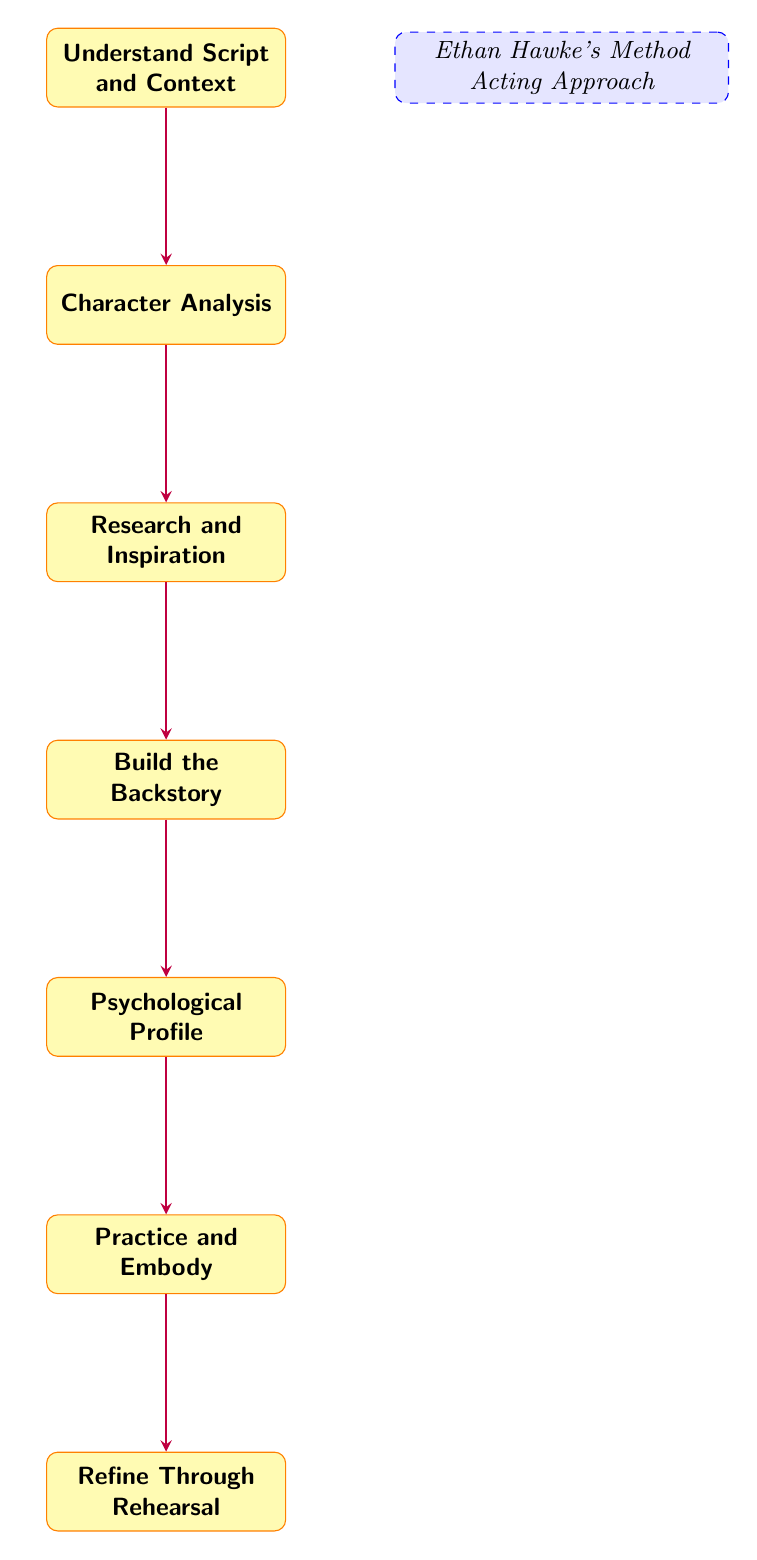What is the first step in the character backstory creation process? The diagram shows "Understand Script and Context" as the first node, indicating it is the initial step in the process.
Answer: Understand Script and Context How many nodes are there in the diagram? By counting the nodes listed in the diagram, there are a total of seven nodes representing steps in the process.
Answer: 7 What is the last step in the process? Looking at the bottom of the flow chart, "Refine Through Rehearsal" is the final node, indicating it is the last step in the character backstory creation process.
Answer: Refine Through Rehearsal What step follows "Character Analysis"? The arrow leading down from "Character Analysis" points to "Research and Inspiration," showing that this is the subsequent step in the flow chart.
Answer: Research and Inspiration Which step develops the character's personality traits? The node labeled "Psychological Profile" directly indicates that this step focuses on developing the character's personality traits, habits, fears, and motivations.
Answer: Psychological Profile How many arrows connect the nodes? The diagram shows six arrows connecting the seven nodes, illustrating the steps’ flow from start to finish.
Answer: 6 What is the relationship between "Build the Backstory" and "Psychological Profile"? The arrow from "Build the Backstory" to "Psychological Profile" indicates a direct connection, where building the backstory leads to the development of the psychological profile.
Answer: Direct connection Which step is specifically about utilizing method acting techniques? "Practice and Embody" explicitly mentions the use of method acting techniques to internalize the character.
Answer: Practice and Embody What concept is highlighted in the dashed box? The dashed box on the right side of the diagram emphasizes "Ethan Hawke's Method Acting Approach," indicating the methodology used throughout the character creation process.
Answer: Ethan Hawke's Method Acting Approach 